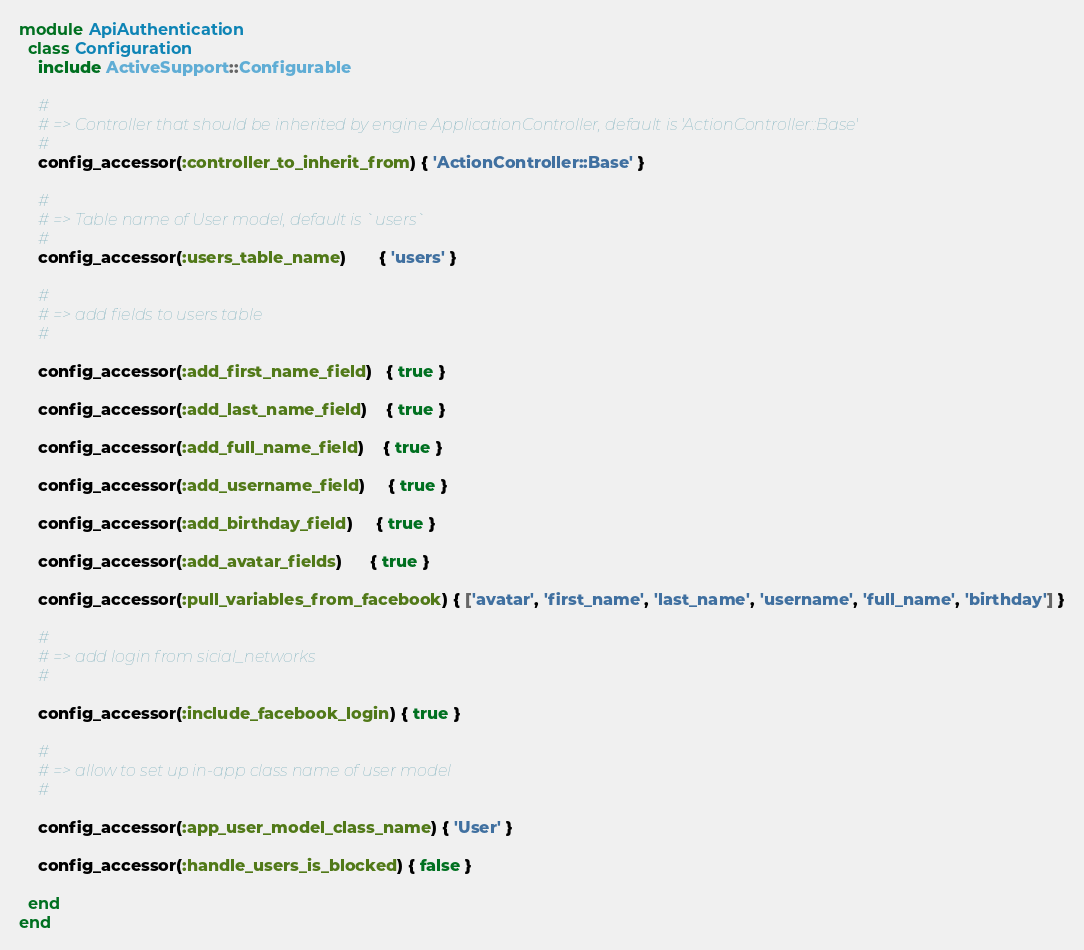Convert code to text. <code><loc_0><loc_0><loc_500><loc_500><_Ruby_>module ApiAuthentication
  class Configuration
    include ActiveSupport::Configurable

    #
    # => Controller that should be inherited by engine ApplicationController, default is 'ActionController::Base'
    #
    config_accessor(:controller_to_inherit_from) { 'ActionController::Base' }

    #
    # => Table name of User model, default is `users`
    #
    config_accessor(:users_table_name)       { 'users' }

    #
    # => add fields to users table
    #

    config_accessor(:add_first_name_field)   { true }

    config_accessor(:add_last_name_field)    { true }

    config_accessor(:add_full_name_field)    { true }

    config_accessor(:add_username_field)     { true }

    config_accessor(:add_birthday_field)     { true }

    config_accessor(:add_avatar_fields)      { true }

    config_accessor(:pull_variables_from_facebook) { ['avatar', 'first_name', 'last_name', 'username', 'full_name', 'birthday'] }

    #
    # => add login from sicial_networks
    #

    config_accessor(:include_facebook_login) { true }

    #
    # => allow to set up in-app class name of user model
    #

    config_accessor(:app_user_model_class_name) { 'User' }

    config_accessor(:handle_users_is_blocked) { false }

  end
end
</code> 